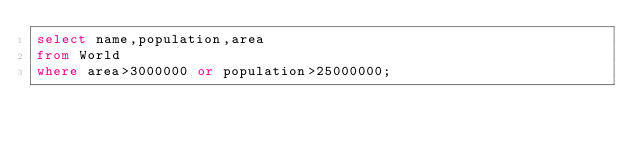Convert code to text. <code><loc_0><loc_0><loc_500><loc_500><_SQL_>select name,population,area
from World
where area>3000000 or population>25000000;</code> 